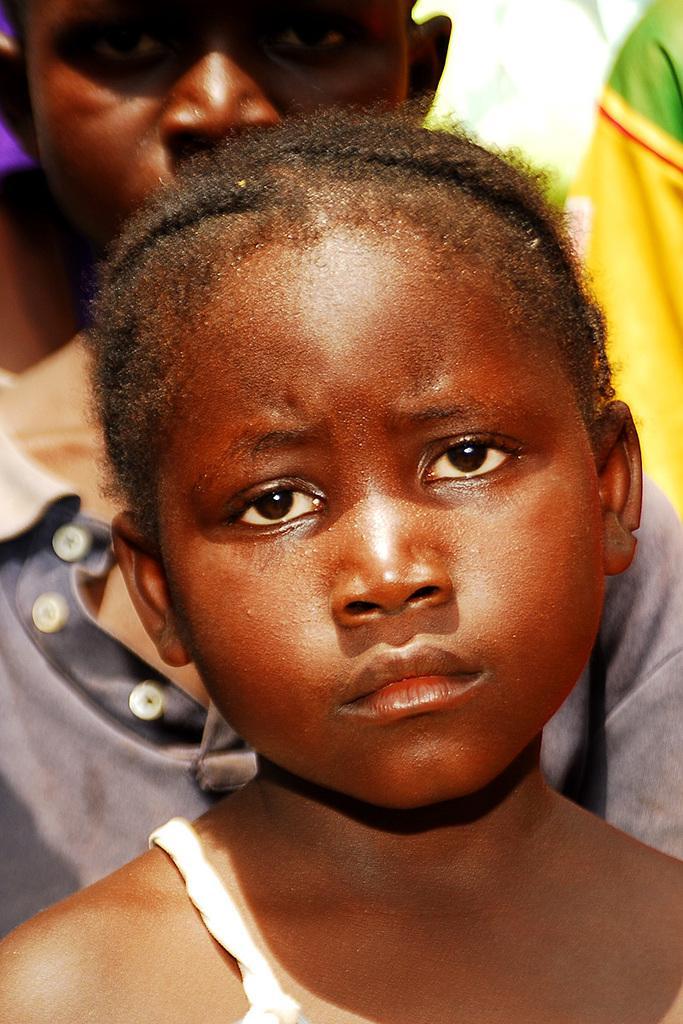Could you give a brief overview of what you see in this image? In this picture we can see two children. 